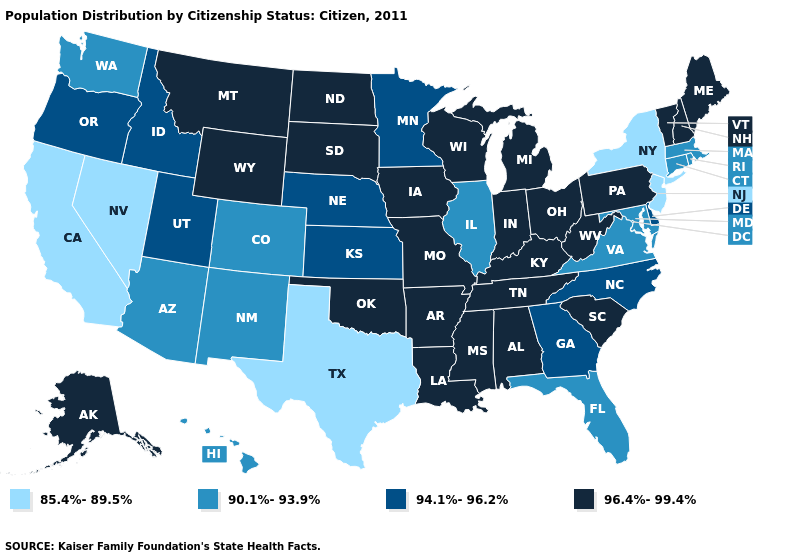Name the states that have a value in the range 96.4%-99.4%?
Give a very brief answer. Alabama, Alaska, Arkansas, Indiana, Iowa, Kentucky, Louisiana, Maine, Michigan, Mississippi, Missouri, Montana, New Hampshire, North Dakota, Ohio, Oklahoma, Pennsylvania, South Carolina, South Dakota, Tennessee, Vermont, West Virginia, Wisconsin, Wyoming. Name the states that have a value in the range 94.1%-96.2%?
Write a very short answer. Delaware, Georgia, Idaho, Kansas, Minnesota, Nebraska, North Carolina, Oregon, Utah. Does Rhode Island have a higher value than Washington?
Give a very brief answer. No. What is the value of Kansas?
Quick response, please. 94.1%-96.2%. Among the states that border Colorado , does Nebraska have the highest value?
Quick response, please. No. Does the first symbol in the legend represent the smallest category?
Short answer required. Yes. What is the lowest value in the USA?
Be succinct. 85.4%-89.5%. What is the value of Maryland?
Give a very brief answer. 90.1%-93.9%. Name the states that have a value in the range 94.1%-96.2%?
Quick response, please. Delaware, Georgia, Idaho, Kansas, Minnesota, Nebraska, North Carolina, Oregon, Utah. What is the value of Louisiana?
Concise answer only. 96.4%-99.4%. What is the value of Kansas?
Answer briefly. 94.1%-96.2%. What is the lowest value in states that border New Jersey?
Short answer required. 85.4%-89.5%. Which states have the highest value in the USA?
Answer briefly. Alabama, Alaska, Arkansas, Indiana, Iowa, Kentucky, Louisiana, Maine, Michigan, Mississippi, Missouri, Montana, New Hampshire, North Dakota, Ohio, Oklahoma, Pennsylvania, South Carolina, South Dakota, Tennessee, Vermont, West Virginia, Wisconsin, Wyoming. Which states have the highest value in the USA?
Keep it brief. Alabama, Alaska, Arkansas, Indiana, Iowa, Kentucky, Louisiana, Maine, Michigan, Mississippi, Missouri, Montana, New Hampshire, North Dakota, Ohio, Oklahoma, Pennsylvania, South Carolina, South Dakota, Tennessee, Vermont, West Virginia, Wisconsin, Wyoming. Name the states that have a value in the range 96.4%-99.4%?
Short answer required. Alabama, Alaska, Arkansas, Indiana, Iowa, Kentucky, Louisiana, Maine, Michigan, Mississippi, Missouri, Montana, New Hampshire, North Dakota, Ohio, Oklahoma, Pennsylvania, South Carolina, South Dakota, Tennessee, Vermont, West Virginia, Wisconsin, Wyoming. 